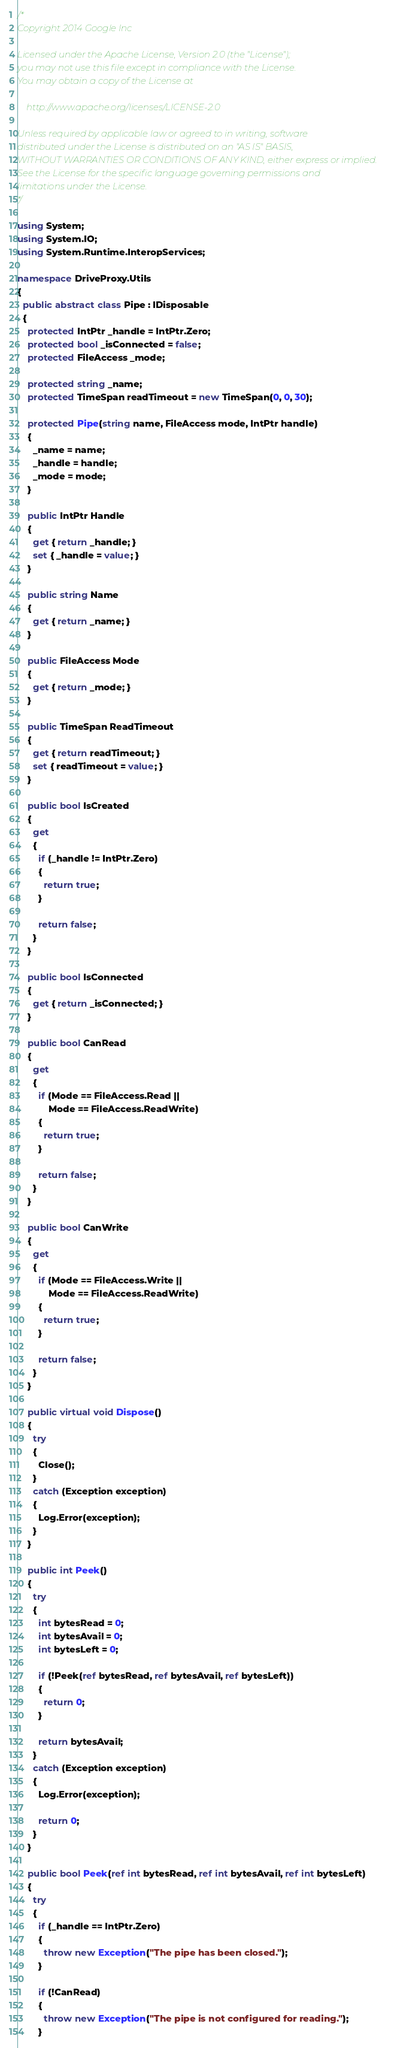Convert code to text. <code><loc_0><loc_0><loc_500><loc_500><_C#_>/*
Copyright 2014 Google Inc

Licensed under the Apache License, Version 2.0 (the "License");
you may not use this file except in compliance with the License.
You may obtain a copy of the License at

    http://www.apache.org/licenses/LICENSE-2.0

Unless required by applicable law or agreed to in writing, software
distributed under the License is distributed on an "AS IS" BASIS,
WITHOUT WARRANTIES OR CONDITIONS OF ANY KIND, either express or implied.
See the License for the specific language governing permissions and
limitations under the License.
*/

using System;
using System.IO;
using System.Runtime.InteropServices;

namespace DriveProxy.Utils
{
  public abstract class Pipe : IDisposable
  {
    protected IntPtr _handle = IntPtr.Zero;
    protected bool _isConnected = false;
    protected FileAccess _mode;

    protected string _name;
    protected TimeSpan readTimeout = new TimeSpan(0, 0, 30);

    protected Pipe(string name, FileAccess mode, IntPtr handle)
    {
      _name = name;
      _handle = handle;
      _mode = mode;
    }

    public IntPtr Handle
    {
      get { return _handle; }
      set { _handle = value; }
    }

    public string Name
    {
      get { return _name; }
    }

    public FileAccess Mode
    {
      get { return _mode; }
    }

    public TimeSpan ReadTimeout
    {
      get { return readTimeout; }
      set { readTimeout = value; }
    }

    public bool IsCreated
    {
      get
      {
        if (_handle != IntPtr.Zero)
        {
          return true;
        }

        return false;
      }
    }

    public bool IsConnected
    {
      get { return _isConnected; }
    }

    public bool CanRead
    {
      get
      {
        if (Mode == FileAccess.Read ||
            Mode == FileAccess.ReadWrite)
        {
          return true;
        }

        return false;
      }
    }

    public bool CanWrite
    {
      get
      {
        if (Mode == FileAccess.Write ||
            Mode == FileAccess.ReadWrite)
        {
          return true;
        }

        return false;
      }
    }

    public virtual void Dispose()
    {
      try
      {
        Close();
      }
      catch (Exception exception)
      {
        Log.Error(exception);
      }
    }

    public int Peek()
    {
      try
      {
        int bytesRead = 0;
        int bytesAvail = 0;
        int bytesLeft = 0;

        if (!Peek(ref bytesRead, ref bytesAvail, ref bytesLeft))
        {
          return 0;
        }

        return bytesAvail;
      }
      catch (Exception exception)
      {
        Log.Error(exception);

        return 0;
      }
    }

    public bool Peek(ref int bytesRead, ref int bytesAvail, ref int bytesLeft)
    {
      try
      {
        if (_handle == IntPtr.Zero)
        {
          throw new Exception("The pipe has been closed.");
        }

        if (!CanRead)
        {
          throw new Exception("The pipe is not configured for reading.");
        }
</code> 